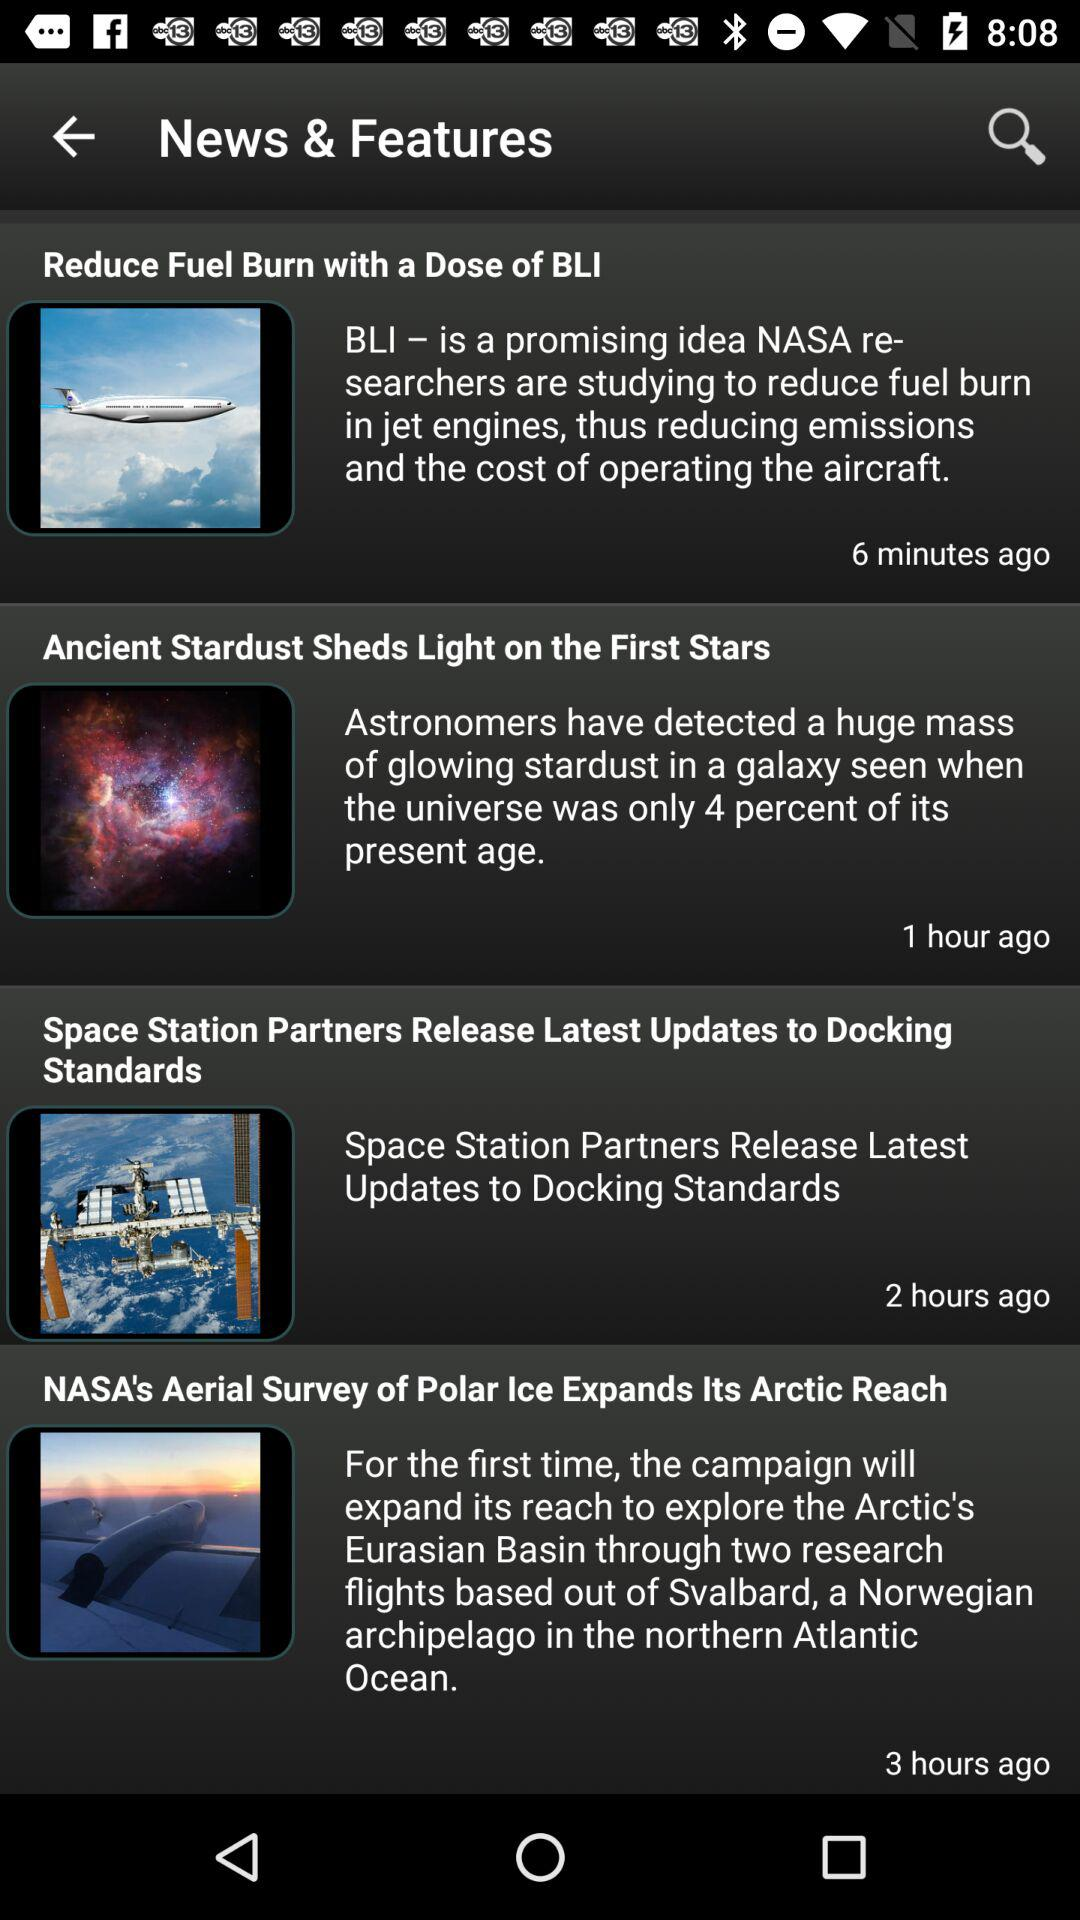How long ago was the news "Space Station Partners Release Latest Updates to Docking Standards" posted? The news "Space Station Partners Release Latest Updates to Docking Standards" was posted 2 hours ago. 